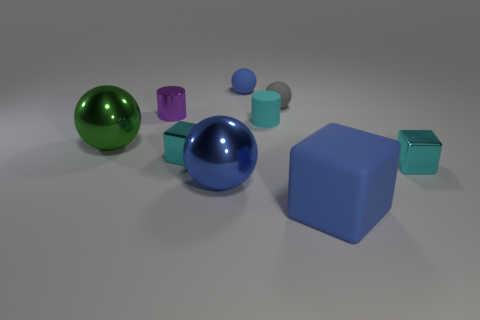Is the size of the cyan metal object on the left side of the blue shiny ball the same as the small cyan rubber object? While both objects feature a notable cyan hue, upon closer inspection, the sizes are quite distinct. The cyan metal object on the left side of the blue shiny ball possesses a larger volume compared to the smaller cyan rubber object. This difference in volume can be attributed to the metal object's longer cylindrical form in contrast to the rubber object's shorter, more compact shape. 